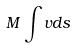Convert formula to latex. <formula><loc_0><loc_0><loc_500><loc_500>M \int v d s</formula> 